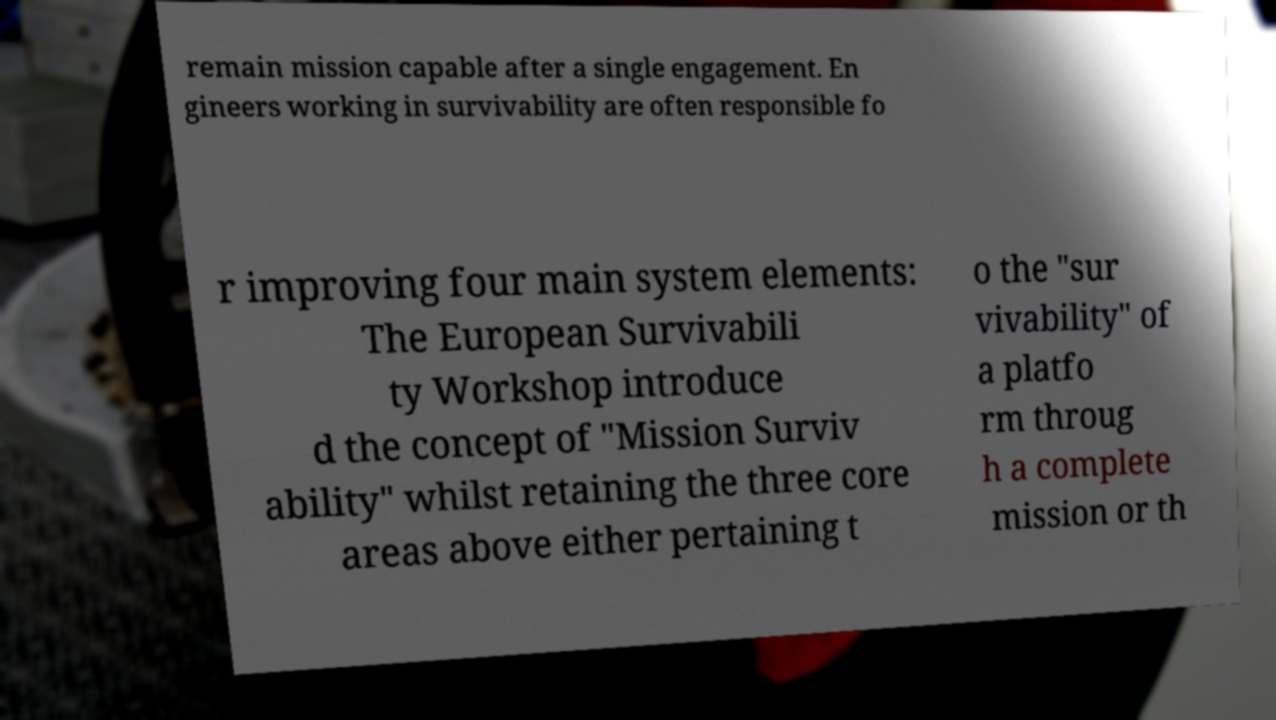I need the written content from this picture converted into text. Can you do that? remain mission capable after a single engagement. En gineers working in survivability are often responsible fo r improving four main system elements: The European Survivabili ty Workshop introduce d the concept of "Mission Surviv ability" whilst retaining the three core areas above either pertaining t o the "sur vivability" of a platfo rm throug h a complete mission or th 